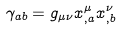<formula> <loc_0><loc_0><loc_500><loc_500>\gamma _ { a b } = g _ { \mu \nu } x ^ { \mu } _ { , a } x ^ { \nu } _ { , b } \,</formula> 